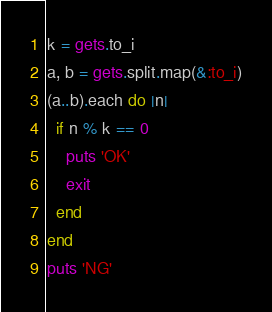<code> <loc_0><loc_0><loc_500><loc_500><_Ruby_>k = gets.to_i
a, b = gets.split.map(&:to_i)
(a..b).each do |n|
  if n % k == 0
    puts 'OK'
    exit
  end
end
puts 'NG'
</code> 